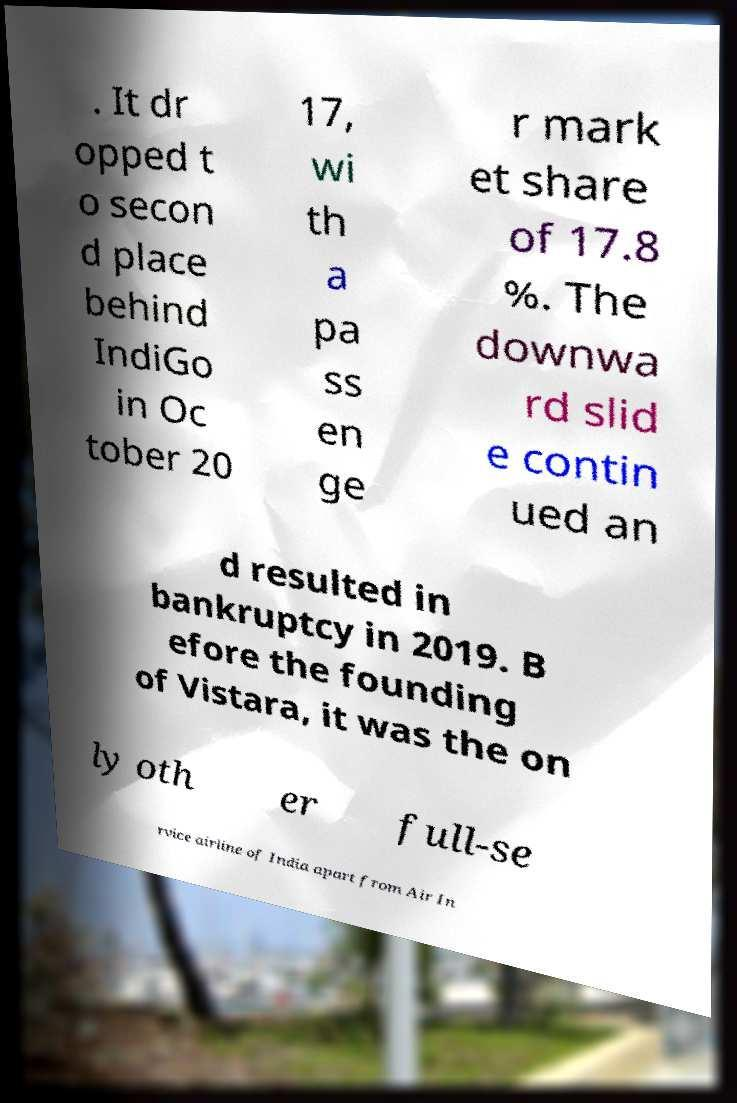Could you extract and type out the text from this image? . It dr opped t o secon d place behind IndiGo in Oc tober 20 17, wi th a pa ss en ge r mark et share of 17.8 %. The downwa rd slid e contin ued an d resulted in bankruptcy in 2019. B efore the founding of Vistara, it was the on ly oth er full-se rvice airline of India apart from Air In 